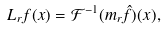<formula> <loc_0><loc_0><loc_500><loc_500>L _ { r } f ( x ) = \mathcal { F } ^ { - 1 } ( m _ { r } \hat { f } ) ( x ) ,</formula> 